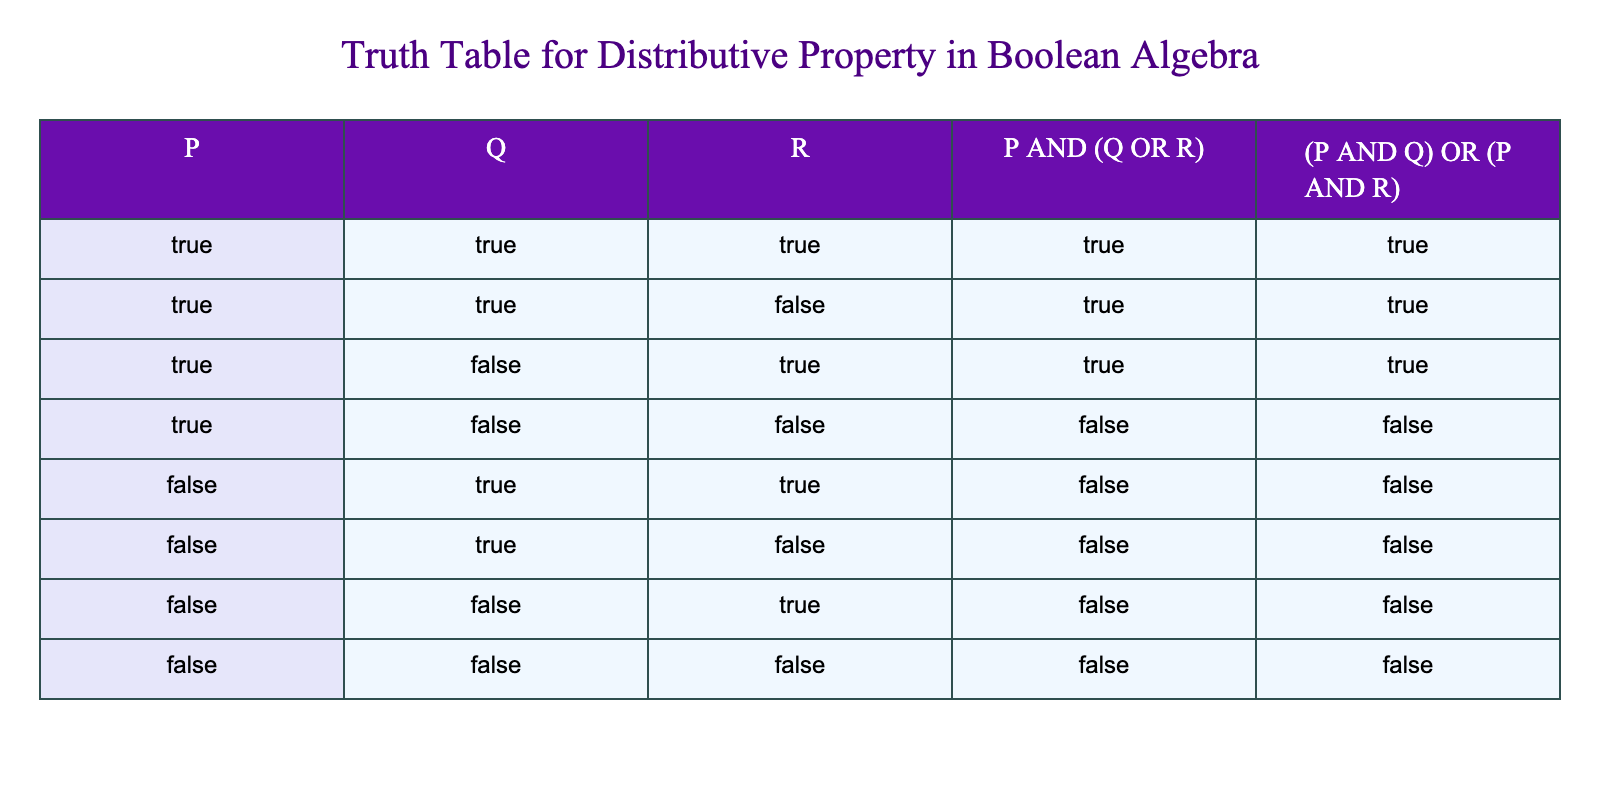What is the value of P AND (Q OR R) when P is True, Q is True, and R is True? In the corresponding row of the table where P, Q, and R are all True, P AND (Q OR R) evaluates to True.
Answer: True What is the value of (P AND Q) OR (P AND R) when P is False, Q is True, and R is False? In the row where P is False, Q is True, and R is False, both P AND Q and P AND R are False, leading to (P AND Q) OR (P AND R) also being False.
Answer: False In how many cases does P AND (Q OR R) evaluate to True? Referring to the rows in the table where P AND (Q OR R) results in True, we find this occurs in three cases: (True, True, True), (True, True, False), and (True, False, True).
Answer: 3 Is (P AND Q) OR (P AND R) always True when P is True? Looking at the rows where P is True, in every such row (True, True, True), (True, True, False), and (True, False, True), (P AND Q) OR (P AND R) remains True, confirming that it holds.
Answer: Yes How many combinations of P, Q, and R yield P AND (Q OR R) as False? By checking each row, we see that P AND (Q OR R) only evaluates to False when P is False, occurring in four cases: (False, True, True), (False, True, False), (False, False, True), and (False, False, False).
Answer: 4 What is the sum of the cases where both expressions evaluate to True? By examining the table, we see that both expressions evaluate to True in three rows: (True, True, True), (True, True, False), and (True, False, True). Therefore, the sum is 3 for the True rows.
Answer: 3 In how many cases is it true that P is False and (P AND Q) OR (P AND R) is also False? From the rows where P is False, we can see that (P AND Q) OR (P AND R) is False in all four of these cases since neither term can be True when P is False.
Answer: 4 What is the value of P AND (Q OR R) when P is True, Q is False, and R is True? In this specific row, the calculation simplifies to True because Q OR R yields True, and True AND True results in True.
Answer: True What is the relationship between the values of P AND (Q OR R) and (P AND Q) OR (P AND R)? By evaluating each row, we see that the values for both expressions are identical across all combinations of P, Q, and R, confirming they are equivalent.
Answer: They are equivalent 